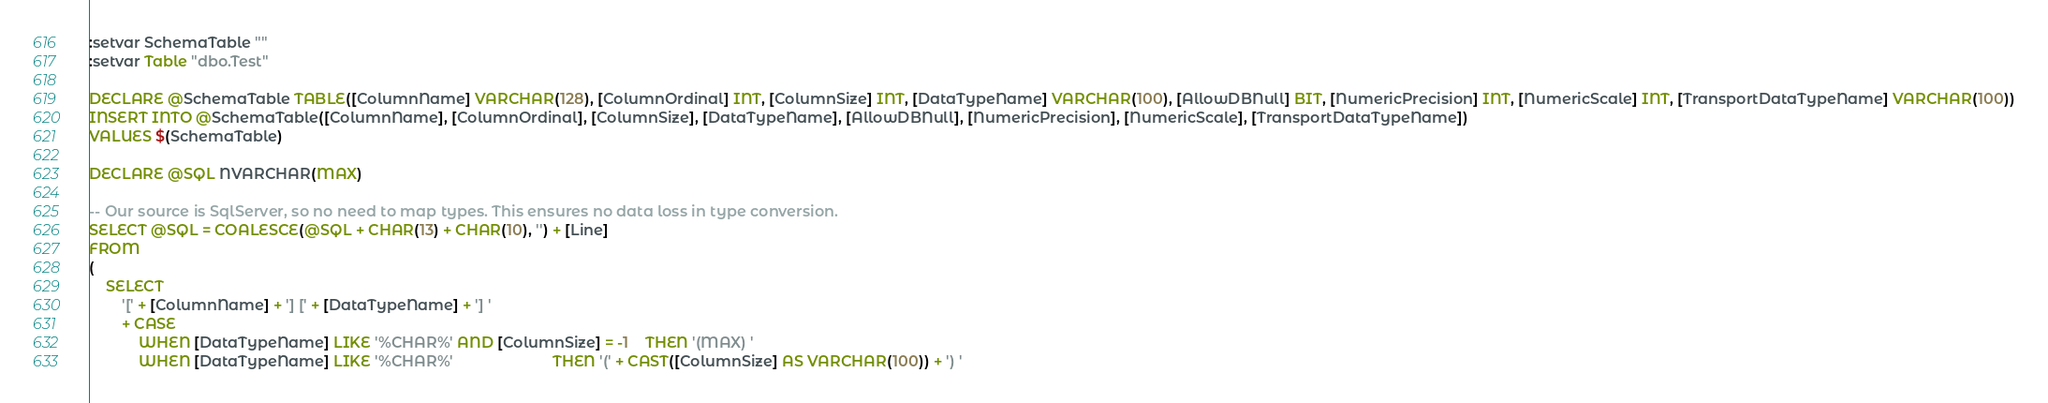Convert code to text. <code><loc_0><loc_0><loc_500><loc_500><_SQL_>:setvar SchemaTable ""
:setvar Table "dbo.Test"

DECLARE @SchemaTable TABLE([ColumnName] VARCHAR(128), [ColumnOrdinal] INT, [ColumnSize] INT, [DataTypeName] VARCHAR(100), [AllowDBNull] BIT, [NumericPrecision] INT, [NumericScale] INT, [TransportDataTypeName] VARCHAR(100))
INSERT INTO @SchemaTable([ColumnName], [ColumnOrdinal], [ColumnSize], [DataTypeName], [AllowDBNull], [NumericPrecision], [NumericScale], [TransportDataTypeName])
VALUES $(SchemaTable)

DECLARE @SQL NVARCHAR(MAX)

-- Our source is SqlServer, so no need to map types. This ensures no data loss in type conversion.
SELECT @SQL = COALESCE(@SQL + CHAR(13) + CHAR(10), '') + [Line]
FROM
(
	SELECT
		'[' + [ColumnName] + '] [' + [DataTypeName] + '] '
		+ CASE 
			WHEN [DataTypeName] LIKE '%CHAR%' AND [ColumnSize] = -1	THEN '(MAX) '
			WHEN [DataTypeName] LIKE '%CHAR%'						THEN '(' + CAST([ColumnSize] AS VARCHAR(100)) + ') '</code> 